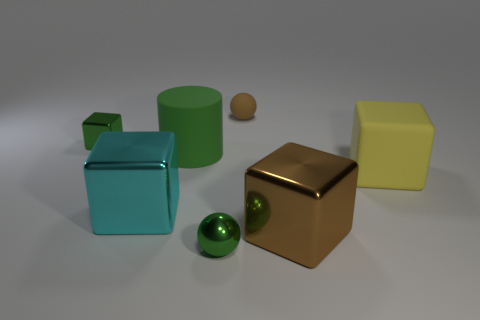Add 2 green cubes. How many objects exist? 9 Subtract all cylinders. How many objects are left? 6 Subtract 0 blue cubes. How many objects are left? 7 Subtract all brown metallic objects. Subtract all big rubber cubes. How many objects are left? 5 Add 2 big cyan metal cubes. How many big cyan metal cubes are left? 3 Add 7 yellow matte objects. How many yellow matte objects exist? 8 